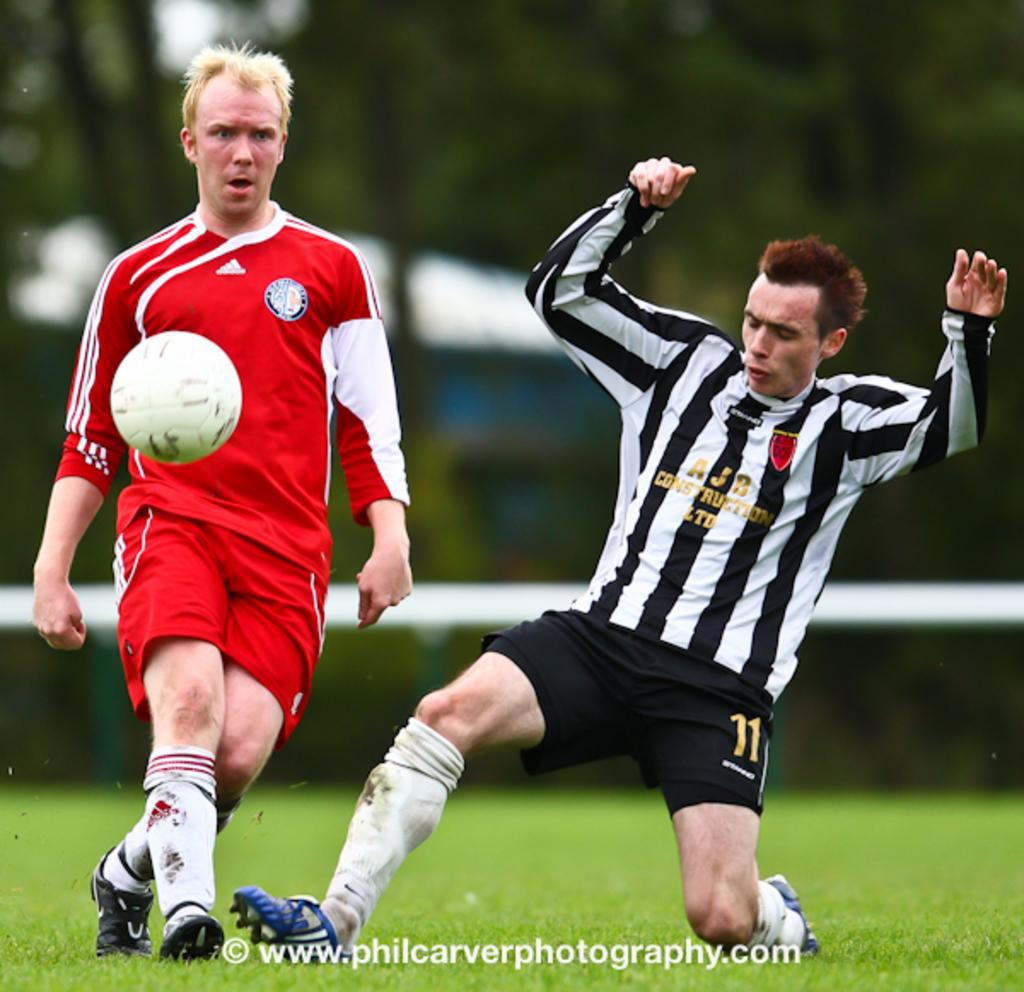<image>
Offer a succinct explanation of the picture presented. A footballer in a black and white striped to sponsered by AJB Construction tackles and opponent wearing red. 